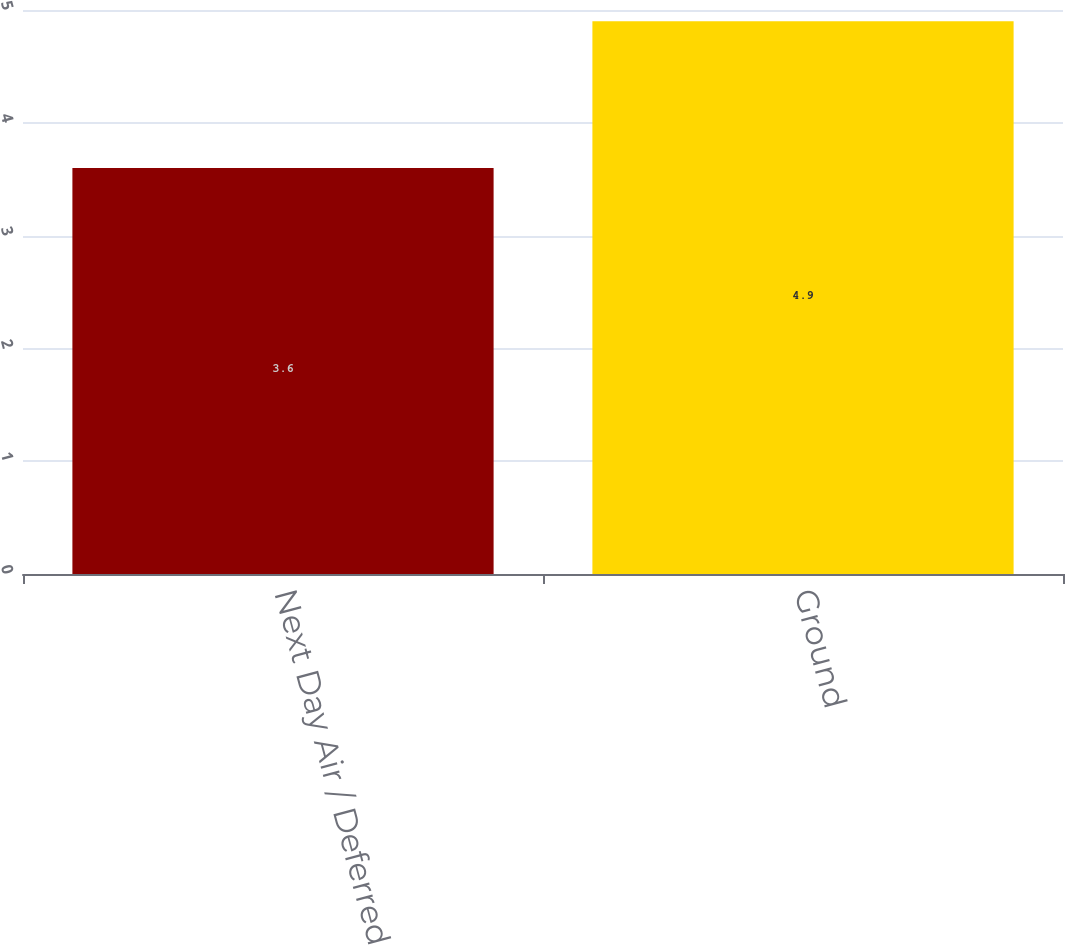<chart> <loc_0><loc_0><loc_500><loc_500><bar_chart><fcel>Next Day Air / Deferred<fcel>Ground<nl><fcel>3.6<fcel>4.9<nl></chart> 